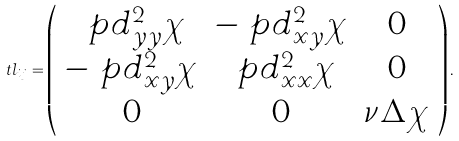Convert formula to latex. <formula><loc_0><loc_0><loc_500><loc_500>\ t l _ { i j } = \left ( \begin{array} { c c c } \ p d ^ { 2 } _ { y y } \chi & - \ p d ^ { 2 } _ { x y } \chi & 0 \\ - \ p d ^ { 2 } _ { x y } \chi & \ p d ^ { 2 } _ { x x } \chi & 0 \\ 0 & 0 & \nu \Delta \chi \end{array} \right ) .</formula> 